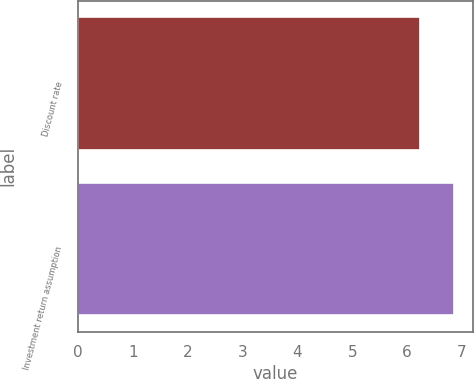Convert chart. <chart><loc_0><loc_0><loc_500><loc_500><bar_chart><fcel>Discount rate<fcel>Investment return assumption<nl><fcel>6.23<fcel>6.86<nl></chart> 